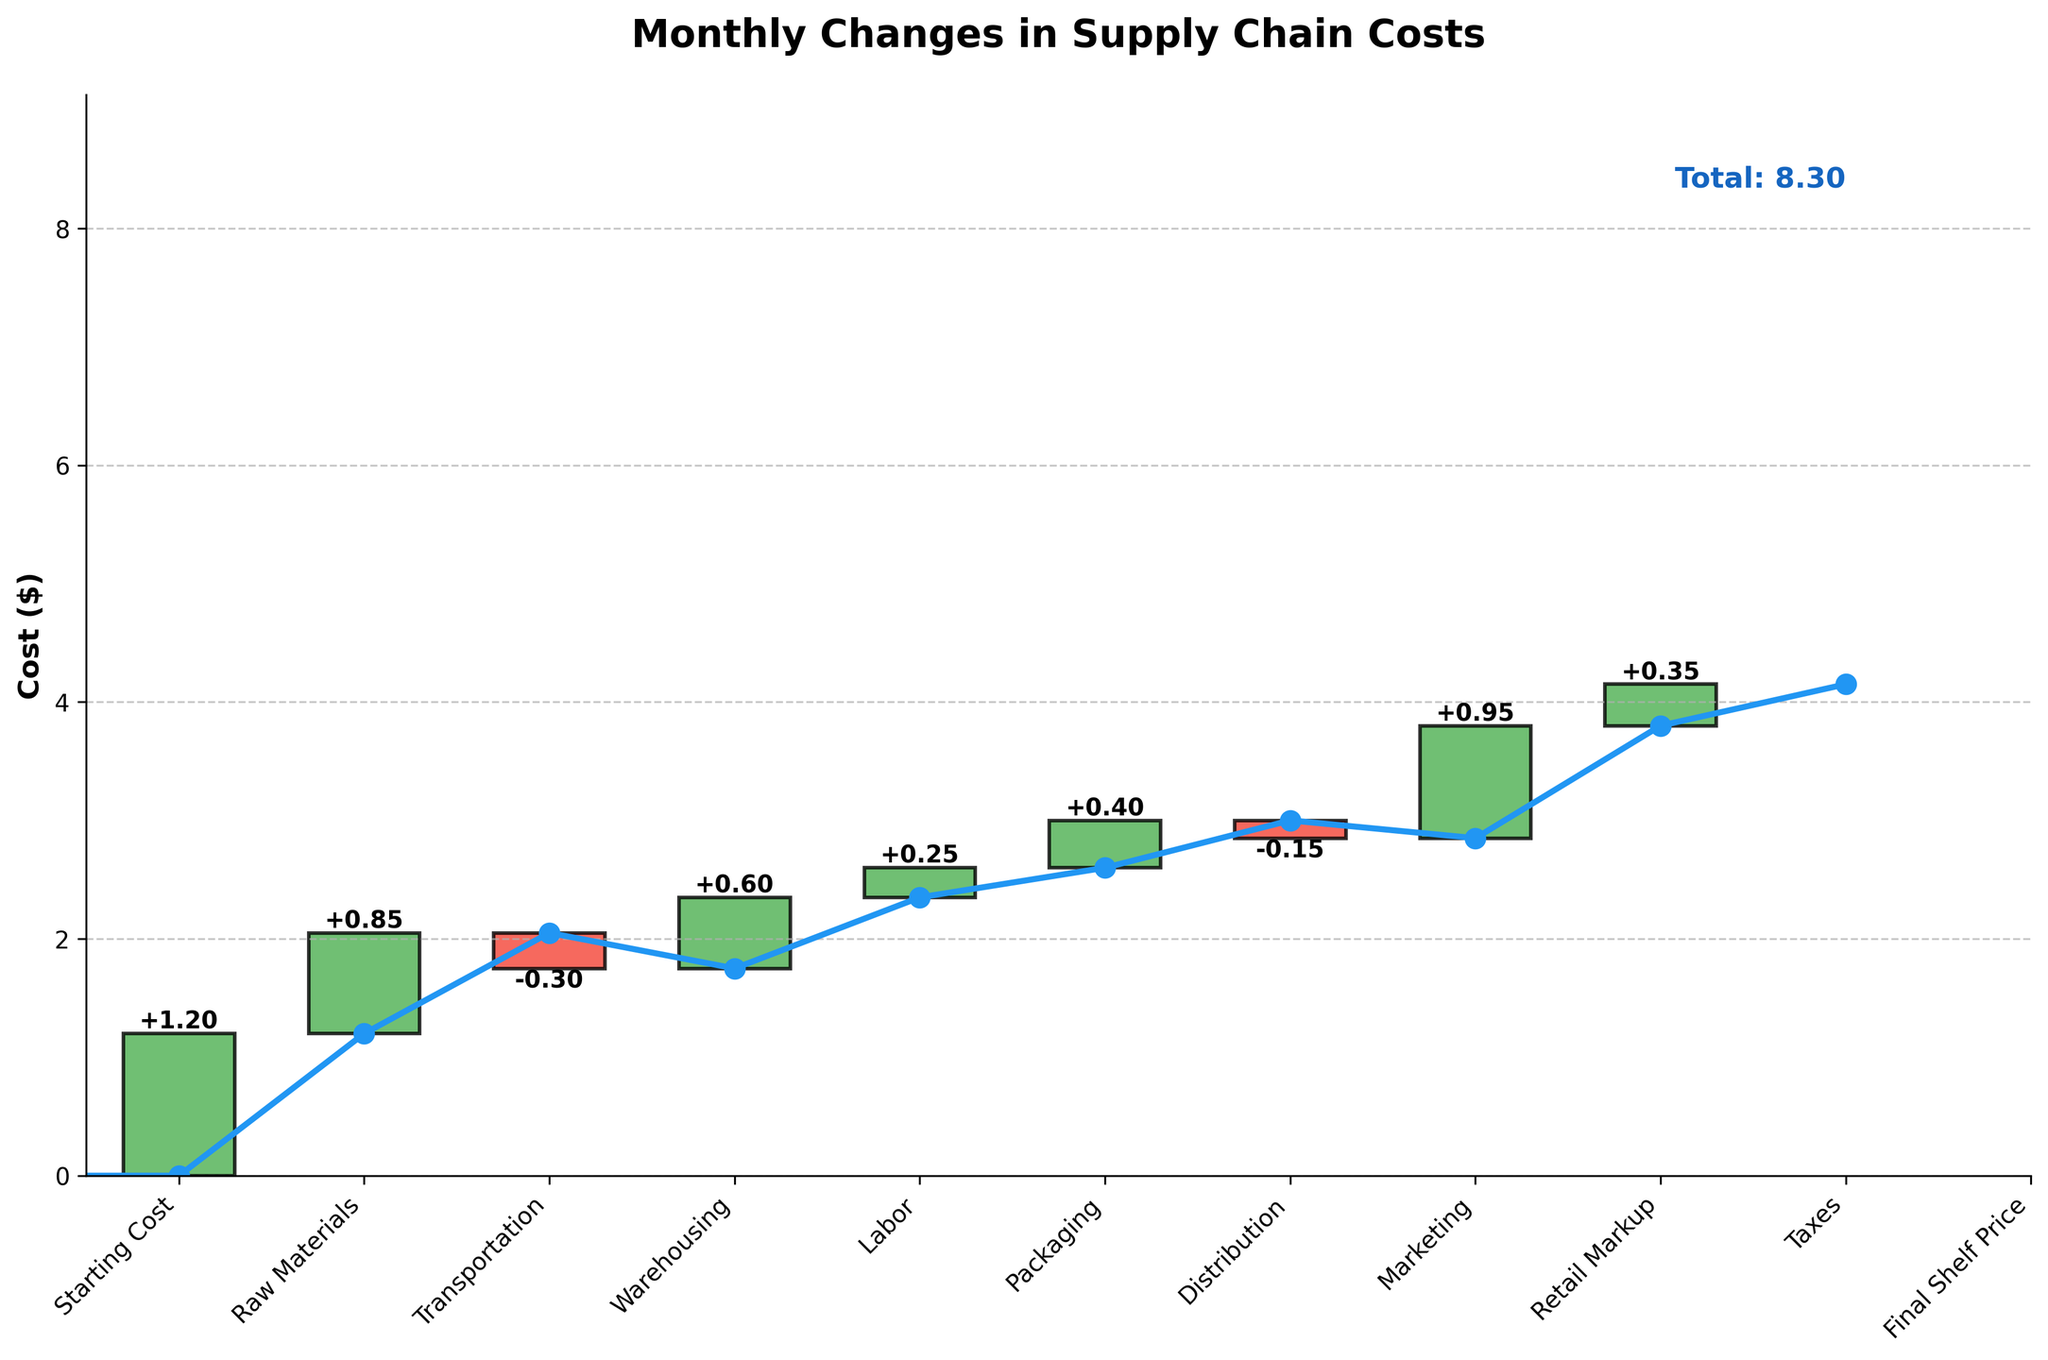What is the title of the plot? The title of the plot is at the top and reads "Monthly Changes in Supply Chain Costs". It is bold and easy to identify.
Answer: Monthly Changes in Supply Chain Costs How many categories are included in the plot? The categories are listed along the x-axis, and a total of 11 categories from "Starting Cost" to "Final Shelf Price" are included.
Answer: 11 Which cost category had the largest increase? By evaluating the height of each bar, "Raw Materials" has the largest positive increase at +1.20.
Answer: Raw Materials Which cost category had a decrease? The red (negative) bars indicate decreases, and there are two such bars: "Warehousing" (-0.30) and "Marketing" (-0.15).
Answer: Warehousing and Marketing What is the cumulative final shelf price? The final cumulative value is shown at the end of the chart next to "Final Shelf Price" and also emphasized with the label "Total: 4.15".
Answer: 4.15 How does the cost of Warehousing compare to Packaging? Warehousing had a decrease of -0.30 while Packaging had an increase of +0.25, indicating Warehousing decreases the cost while Packaging increases it.
Answer: Warehousing decreases, Packaging increases By how much does the Transportation cost contribute to the final shelf price? The height of the "Transportation" bar shows it adds +0.85 to the final shelf price.
Answer: 0.85 What is the overall net change in costs from the starting cost to the final shelf price? The overall net change in costs is the cumulative total at the end, which is 4.15, meaning all intermediate steps added up results in a final net change of 4.15.
Answer: 4.15 Which cost component is the smallest in magnitude, either positive or negative? Among all the bars, "Marketing" has the smallest value at -0.15.
Answer: Marketing What is the total increase in costs excluding any decreases? Excluding decreases (-0.30 and -0.15), sum the positive changes: 1.20 + 0.85 + 0.60 + 0.25 + 0.40 + 0.95 + 0.35 = 4.60.
Answer: 4.60 